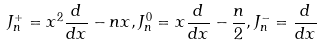<formula> <loc_0><loc_0><loc_500><loc_500>J ^ { + } _ { n } = x ^ { 2 } \frac { d } { d x } - n x , J ^ { 0 } _ { n } = x \frac { d } { d x } - \frac { n } { 2 } , J ^ { - } _ { n } = \frac { d } { d x }</formula> 